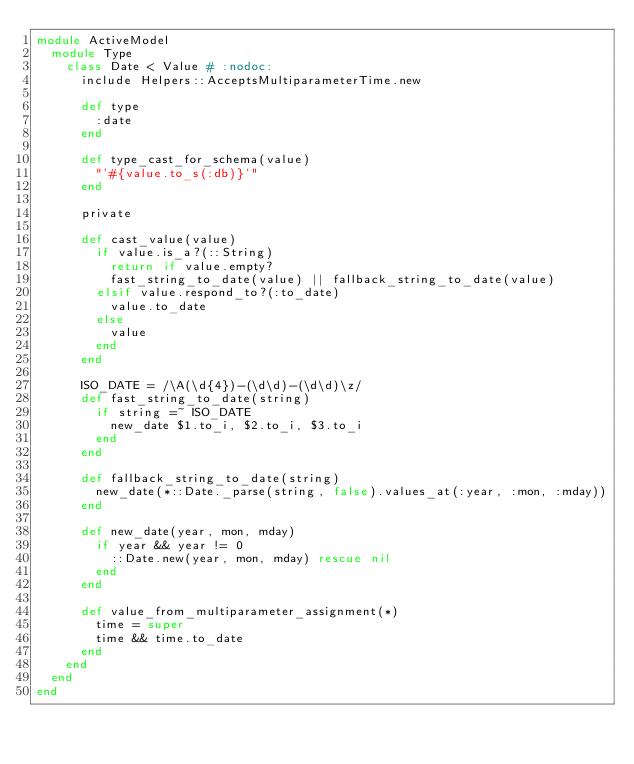Convert code to text. <code><loc_0><loc_0><loc_500><loc_500><_Ruby_>module ActiveModel
  module Type
    class Date < Value # :nodoc:
      include Helpers::AcceptsMultiparameterTime.new

      def type
        :date
      end

      def type_cast_for_schema(value)
        "'#{value.to_s(:db)}'"
      end

      private

      def cast_value(value)
        if value.is_a?(::String)
          return if value.empty?
          fast_string_to_date(value) || fallback_string_to_date(value)
        elsif value.respond_to?(:to_date)
          value.to_date
        else
          value
        end
      end

      ISO_DATE = /\A(\d{4})-(\d\d)-(\d\d)\z/
      def fast_string_to_date(string)
        if string =~ ISO_DATE
          new_date $1.to_i, $2.to_i, $3.to_i
        end
      end

      def fallback_string_to_date(string)
        new_date(*::Date._parse(string, false).values_at(:year, :mon, :mday))
      end

      def new_date(year, mon, mday)
        if year && year != 0
          ::Date.new(year, mon, mday) rescue nil
        end
      end

      def value_from_multiparameter_assignment(*)
        time = super
        time && time.to_date
      end
    end
  end
end
</code> 